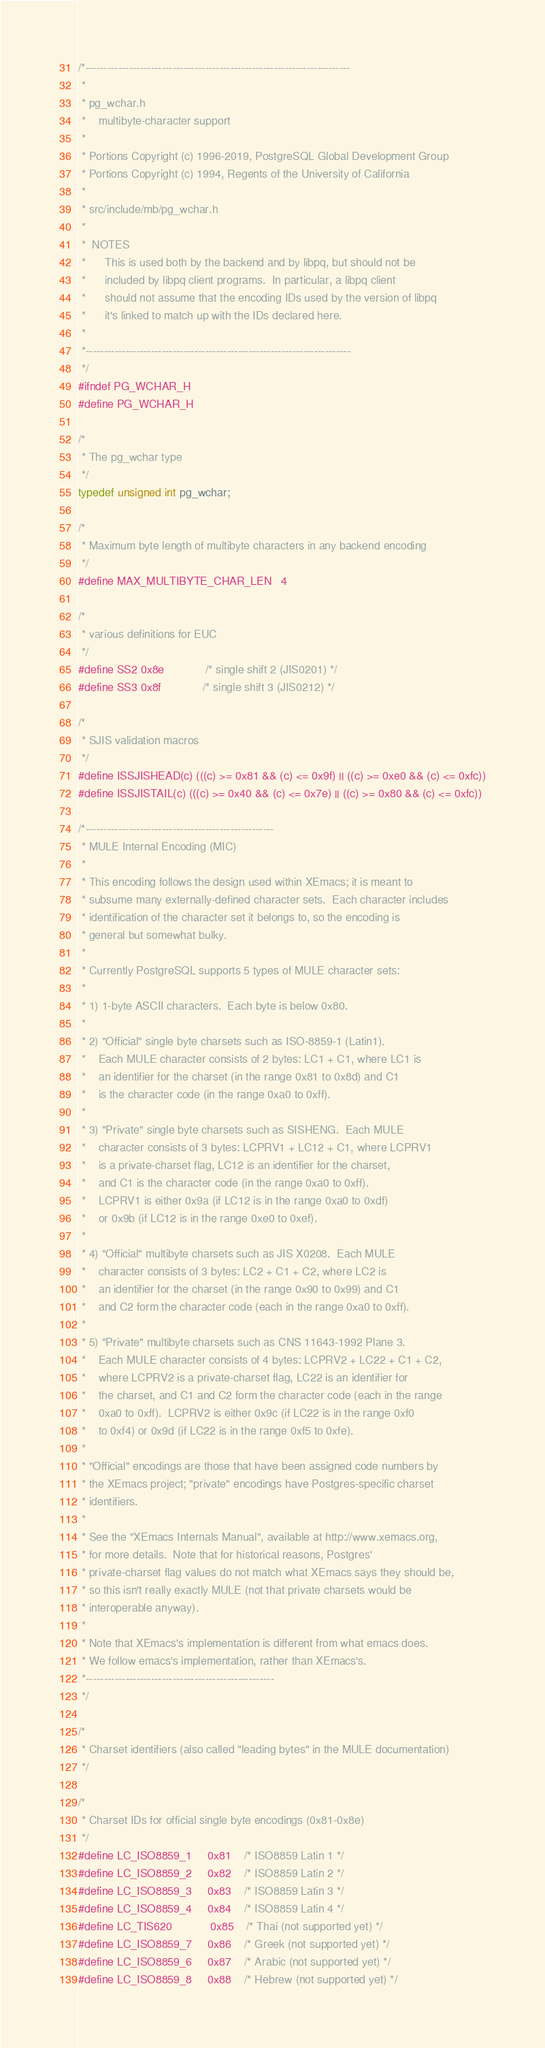<code> <loc_0><loc_0><loc_500><loc_500><_C_>/*-------------------------------------------------------------------------
 *
 * pg_wchar.h
 *	  multibyte-character support
 *
 * Portions Copyright (c) 1996-2019, PostgreSQL Global Development Group
 * Portions Copyright (c) 1994, Regents of the University of California
 *
 * src/include/mb/pg_wchar.h
 *
 *	NOTES
 *		This is used both by the backend and by libpq, but should not be
 *		included by libpq client programs.  In particular, a libpq client
 *		should not assume that the encoding IDs used by the version of libpq
 *		it's linked to match up with the IDs declared here.
 *
 *-------------------------------------------------------------------------
 */
#ifndef PG_WCHAR_H
#define PG_WCHAR_H

/*
 * The pg_wchar type
 */
typedef unsigned int pg_wchar;

/*
 * Maximum byte length of multibyte characters in any backend encoding
 */
#define MAX_MULTIBYTE_CHAR_LEN	4

/*
 * various definitions for EUC
 */
#define SS2 0x8e				/* single shift 2 (JIS0201) */
#define SS3 0x8f				/* single shift 3 (JIS0212) */

/*
 * SJIS validation macros
 */
#define ISSJISHEAD(c) (((c) >= 0x81 && (c) <= 0x9f) || ((c) >= 0xe0 && (c) <= 0xfc))
#define ISSJISTAIL(c) (((c) >= 0x40 && (c) <= 0x7e) || ((c) >= 0x80 && (c) <= 0xfc))

/*----------------------------------------------------
 * MULE Internal Encoding (MIC)
 *
 * This encoding follows the design used within XEmacs; it is meant to
 * subsume many externally-defined character sets.  Each character includes
 * identification of the character set it belongs to, so the encoding is
 * general but somewhat bulky.
 *
 * Currently PostgreSQL supports 5 types of MULE character sets:
 *
 * 1) 1-byte ASCII characters.  Each byte is below 0x80.
 *
 * 2) "Official" single byte charsets such as ISO-8859-1 (Latin1).
 *	  Each MULE character consists of 2 bytes: LC1 + C1, where LC1 is
 *	  an identifier for the charset (in the range 0x81 to 0x8d) and C1
 *	  is the character code (in the range 0xa0 to 0xff).
 *
 * 3) "Private" single byte charsets such as SISHENG.  Each MULE
 *	  character consists of 3 bytes: LCPRV1 + LC12 + C1, where LCPRV1
 *	  is a private-charset flag, LC12 is an identifier for the charset,
 *	  and C1 is the character code (in the range 0xa0 to 0xff).
 *	  LCPRV1 is either 0x9a (if LC12 is in the range 0xa0 to 0xdf)
 *	  or 0x9b (if LC12 is in the range 0xe0 to 0xef).
 *
 * 4) "Official" multibyte charsets such as JIS X0208.  Each MULE
 *	  character consists of 3 bytes: LC2 + C1 + C2, where LC2 is
 *	  an identifier for the charset (in the range 0x90 to 0x99) and C1
 *	  and C2 form the character code (each in the range 0xa0 to 0xff).
 *
 * 5) "Private" multibyte charsets such as CNS 11643-1992 Plane 3.
 *	  Each MULE character consists of 4 bytes: LCPRV2 + LC22 + C1 + C2,
 *	  where LCPRV2 is a private-charset flag, LC22 is an identifier for
 *	  the charset, and C1 and C2 form the character code (each in the range
 *	  0xa0 to 0xff).  LCPRV2 is either 0x9c (if LC22 is in the range 0xf0
 *	  to 0xf4) or 0x9d (if LC22 is in the range 0xf5 to 0xfe).
 *
 * "Official" encodings are those that have been assigned code numbers by
 * the XEmacs project; "private" encodings have Postgres-specific charset
 * identifiers.
 *
 * See the "XEmacs Internals Manual", available at http://www.xemacs.org,
 * for more details.  Note that for historical reasons, Postgres'
 * private-charset flag values do not match what XEmacs says they should be,
 * so this isn't really exactly MULE (not that private charsets would be
 * interoperable anyway).
 *
 * Note that XEmacs's implementation is different from what emacs does.
 * We follow emacs's implementation, rather than XEmacs's.
 *----------------------------------------------------
 */

/*
 * Charset identifiers (also called "leading bytes" in the MULE documentation)
 */

/*
 * Charset IDs for official single byte encodings (0x81-0x8e)
 */
#define LC_ISO8859_1		0x81	/* ISO8859 Latin 1 */
#define LC_ISO8859_2		0x82	/* ISO8859 Latin 2 */
#define LC_ISO8859_3		0x83	/* ISO8859 Latin 3 */
#define LC_ISO8859_4		0x84	/* ISO8859 Latin 4 */
#define LC_TIS620			0x85	/* Thai (not supported yet) */
#define LC_ISO8859_7		0x86	/* Greek (not supported yet) */
#define LC_ISO8859_6		0x87	/* Arabic (not supported yet) */
#define LC_ISO8859_8		0x88	/* Hebrew (not supported yet) */</code> 